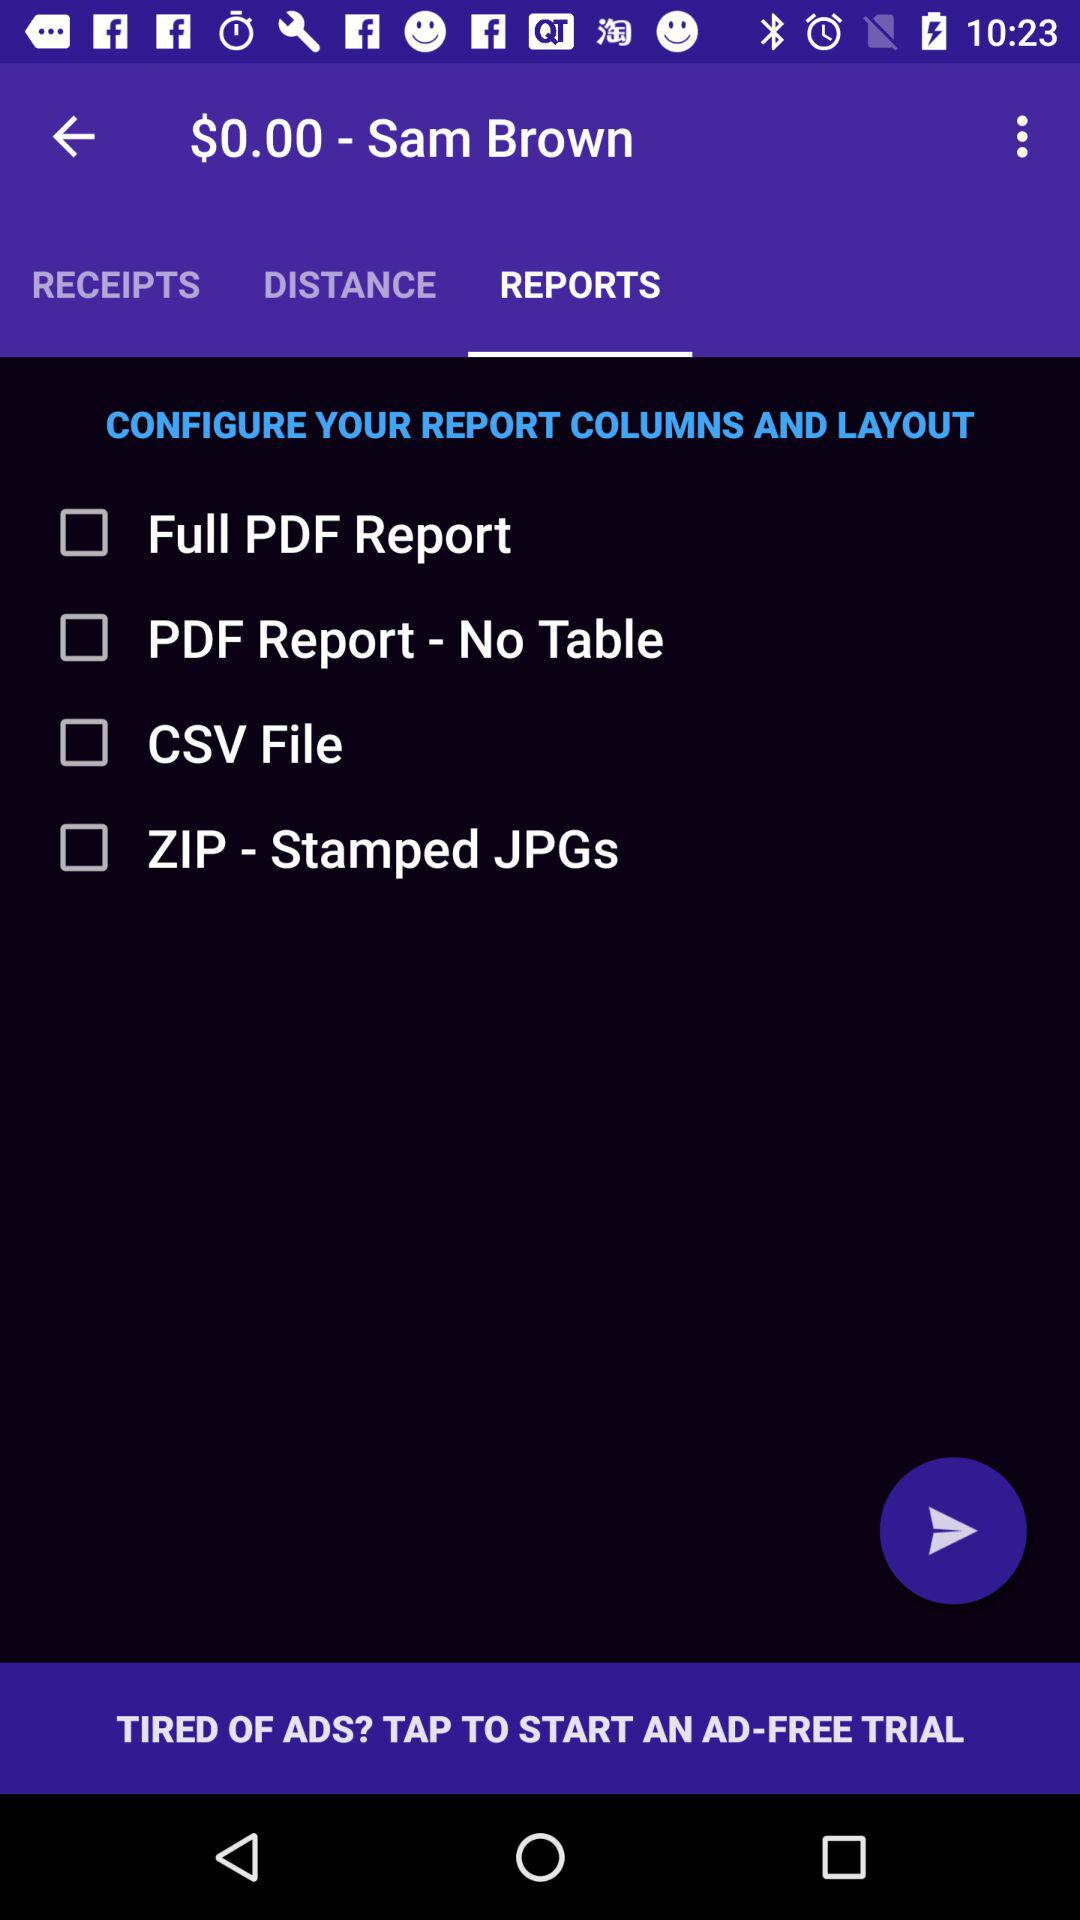How many report formats are available?
Answer the question using a single word or phrase. 4 